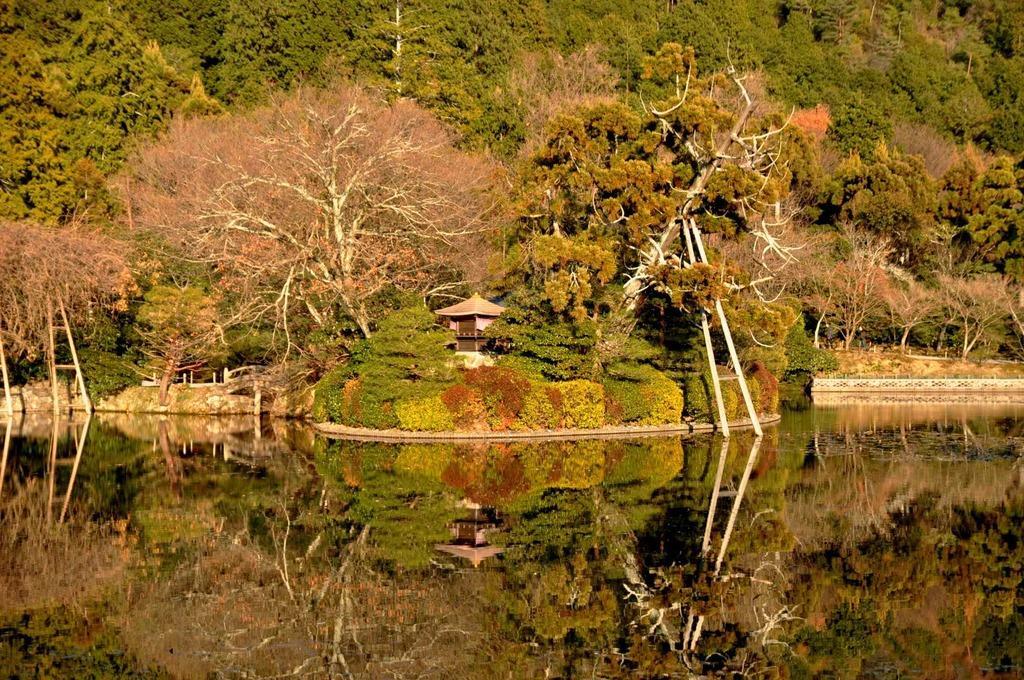Can you describe this image briefly? In this image I can see few trees in green and brown color. I can see the house and the water. 